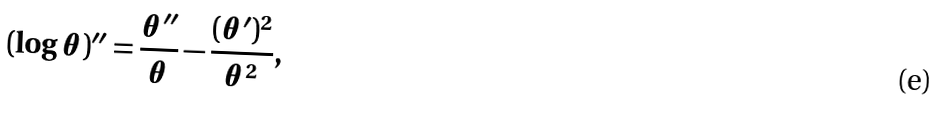<formula> <loc_0><loc_0><loc_500><loc_500>( \log \theta ) ^ { \prime \prime } = \frac { \theta ^ { \prime \prime } } { \theta } - \frac { ( \theta ^ { \prime } ) ^ { 2 } } { \theta ^ { 2 } } ,</formula> 